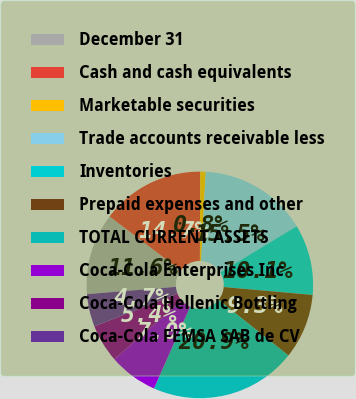<chart> <loc_0><loc_0><loc_500><loc_500><pie_chart><fcel>December 31<fcel>Cash and cash equivalents<fcel>Marketable securities<fcel>Trade accounts receivable less<fcel>Inventories<fcel>Prepaid expenses and other<fcel>TOTAL CURRENT ASSETS<fcel>Coca-Cola Enterprises Inc<fcel>Coca-Cola Hellenic Bottling<fcel>Coca-Cola FEMSA SAB de CV<nl><fcel>11.63%<fcel>14.73%<fcel>0.78%<fcel>15.5%<fcel>10.08%<fcel>9.3%<fcel>20.92%<fcel>6.98%<fcel>5.43%<fcel>4.66%<nl></chart> 